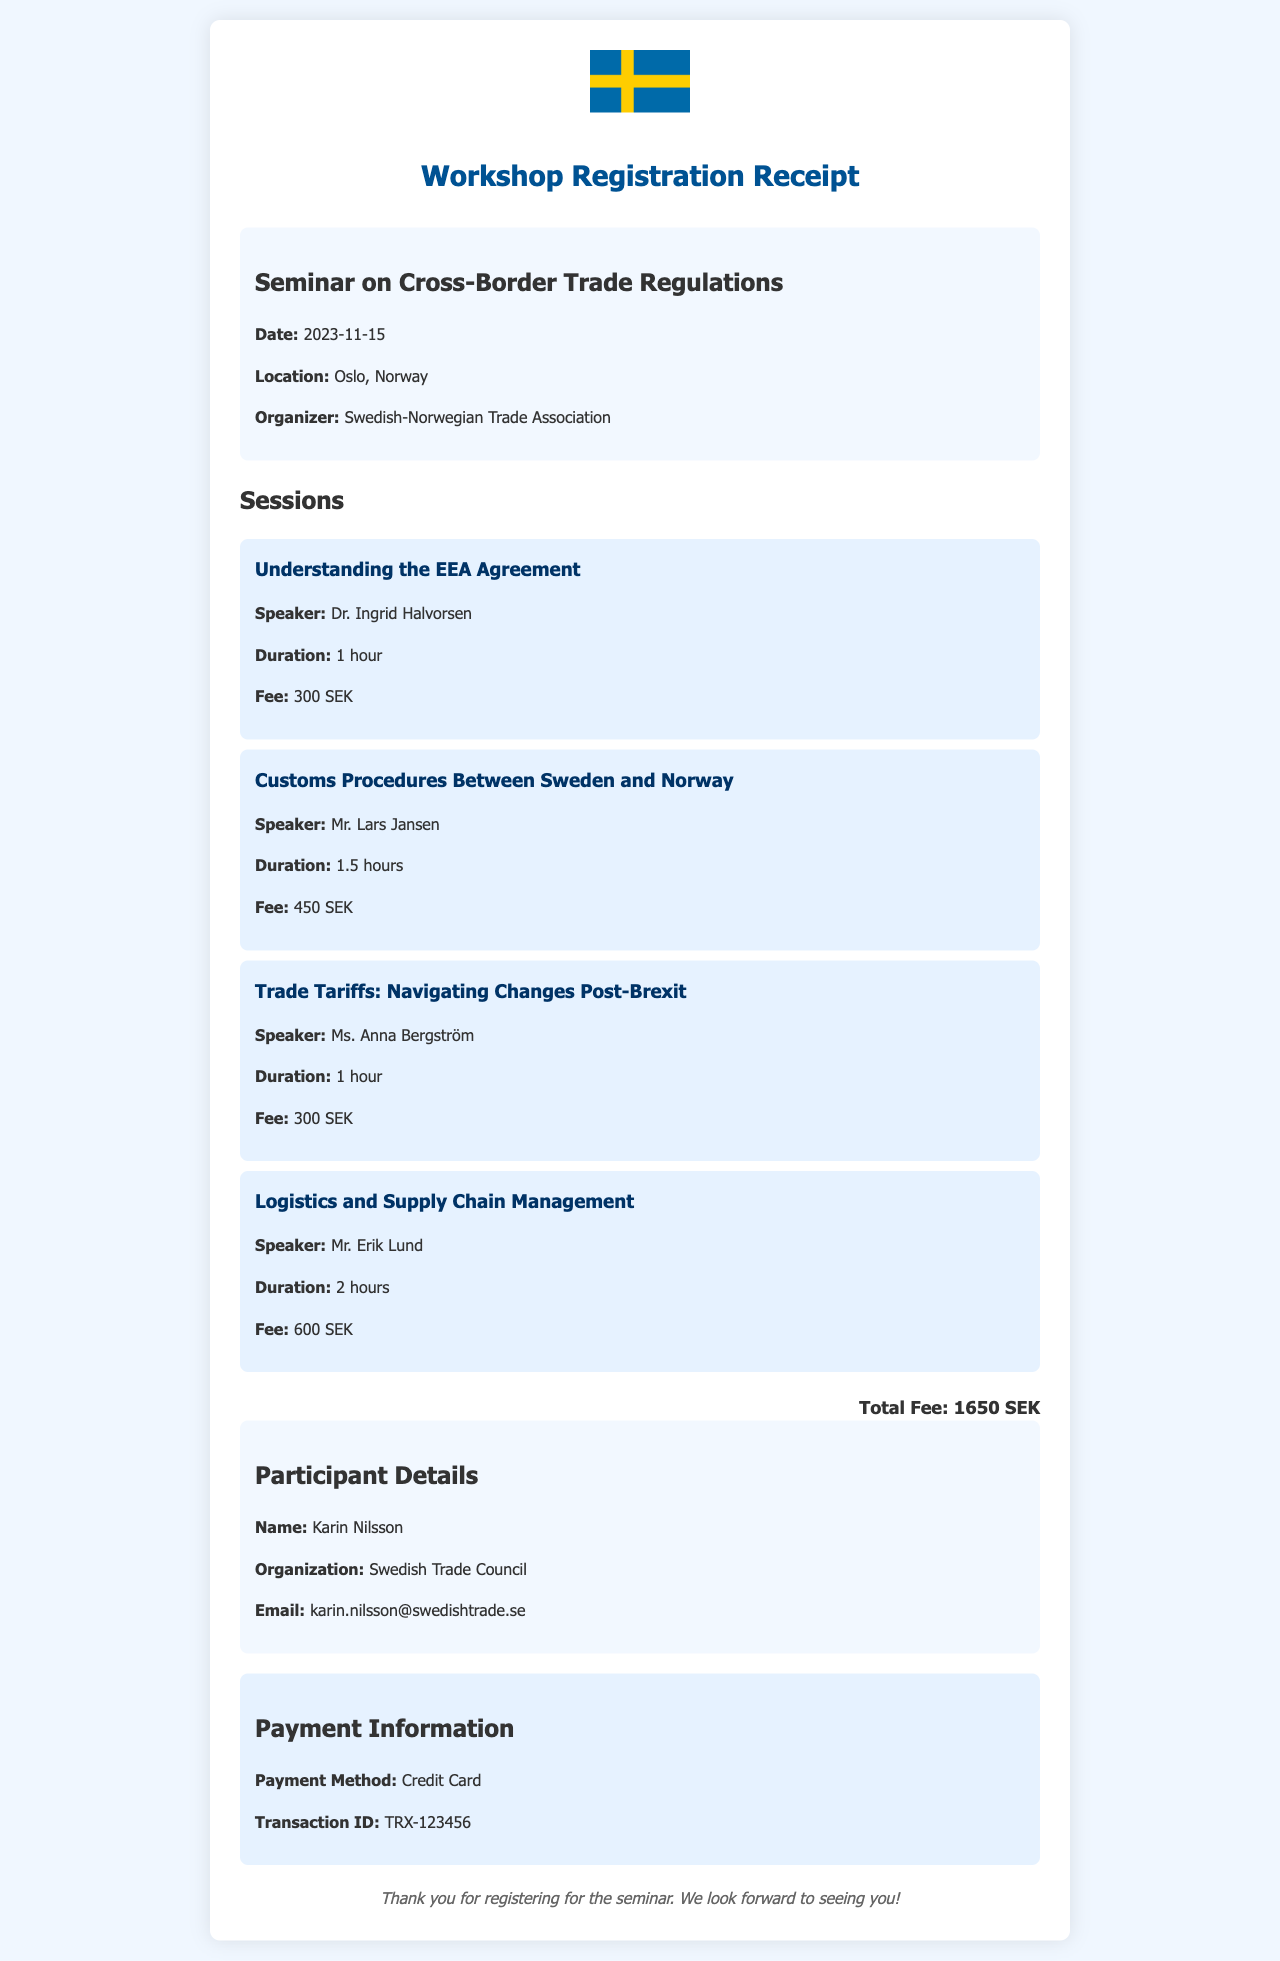What is the seminar title? The document mentions that the seminar is on "Cross-Border Trade Regulations."
Answer: Cross-Border Trade Regulations What is the location of the seminar? According to the document, the seminar will take place in Oslo, Norway.
Answer: Oslo, Norway Who is the speaker for the session on Customs Procedures? The session on Customs Procedures features Mr. Lars Jansen as the speaker.
Answer: Mr. Lars Jansen What is the total fee for the workshop? The document states that the total fee for the workshop is 1650 SEK.
Answer: 1650 SEK How long is the session on Logistics and Supply Chain Management? The duration of the Logistics and Supply Chain Management session is specified as 2 hours.
Answer: 2 hours What payment method was used for the registration? The payment method listed in the document is Credit Card.
Answer: Credit Card Who registered for the seminar? The participant registered under the name Karin Nilsson.
Answer: Karin Nilsson Which organization is the participant affiliated with? The document indicates that the participant is from the Swedish Trade Council.
Answer: Swedish Trade Council What is the transaction ID for the payment? The registration receipt provides the transaction ID as TRX-123456.
Answer: TRX-123456 